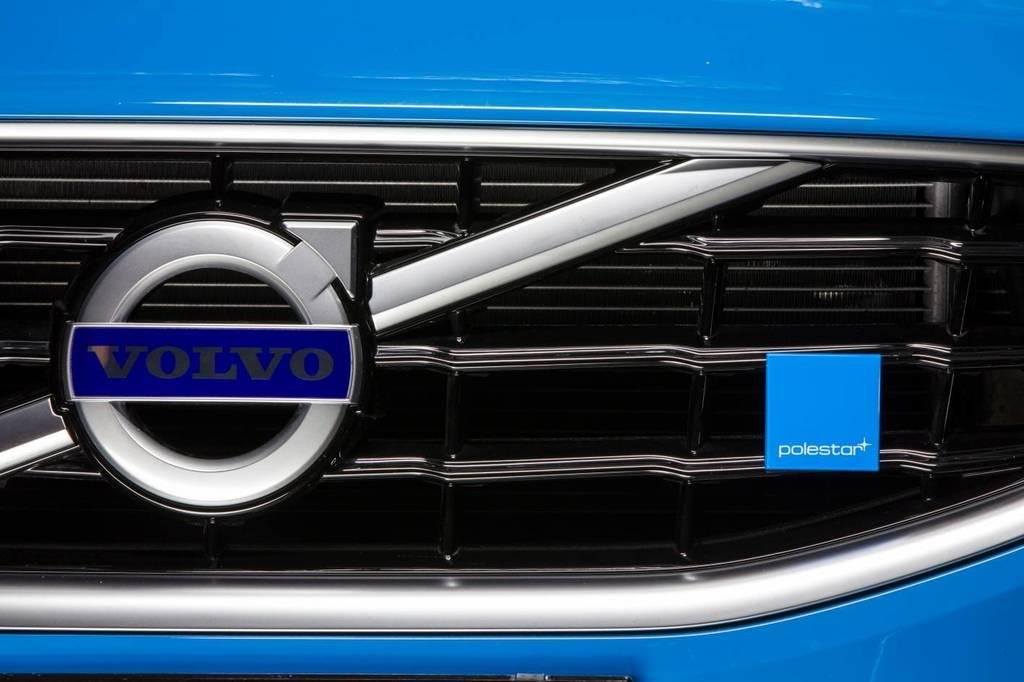What type of vehicle is partially visible in the image? There is a part of a vehicle in the image, but the specific type cannot be determined from the provided facts. What can be seen attached to the grille of the vehicle? There is a logo attached to the grille of the vehicle. How many pins are holding the sink in place in the image? There is no sink present in the image, so it is not possible to determine how many pins might be holding it in place. 